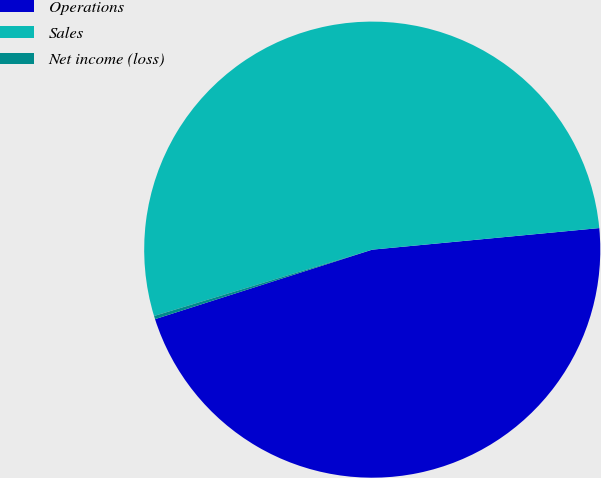Convert chart. <chart><loc_0><loc_0><loc_500><loc_500><pie_chart><fcel>Operations<fcel>Sales<fcel>Net income (loss)<nl><fcel>46.58%<fcel>53.19%<fcel>0.23%<nl></chart> 